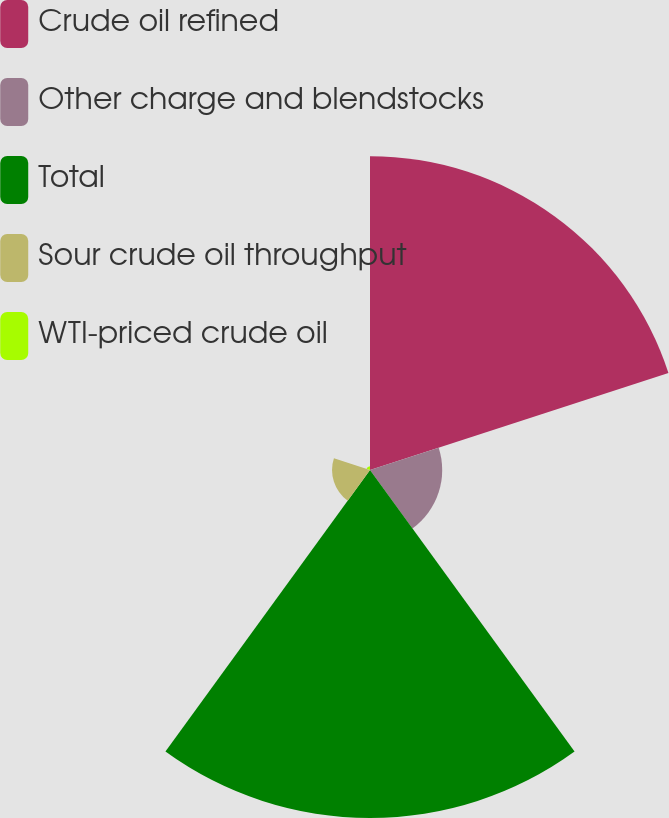Convert chart to OTSL. <chart><loc_0><loc_0><loc_500><loc_500><pie_chart><fcel>Crude oil refined<fcel>Other charge and blendstocks<fcel>Total<fcel>Sour crude oil throughput<fcel>WTI-priced crude oil<nl><fcel>40.46%<fcel>9.31%<fcel>44.87%<fcel>4.89%<fcel>0.47%<nl></chart> 